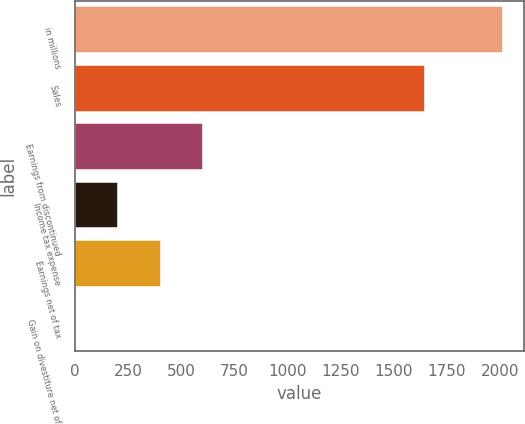Convert chart to OTSL. <chart><loc_0><loc_0><loc_500><loc_500><bar_chart><fcel>in millions<fcel>Sales<fcel>Earnings from discontinued<fcel>Income tax expense<fcel>Earnings net of tax<fcel>Gain on divestiture net of<nl><fcel>2011<fcel>1646<fcel>604<fcel>202<fcel>403<fcel>1<nl></chart> 